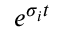<formula> <loc_0><loc_0><loc_500><loc_500>e ^ { \sigma _ { i } t }</formula> 